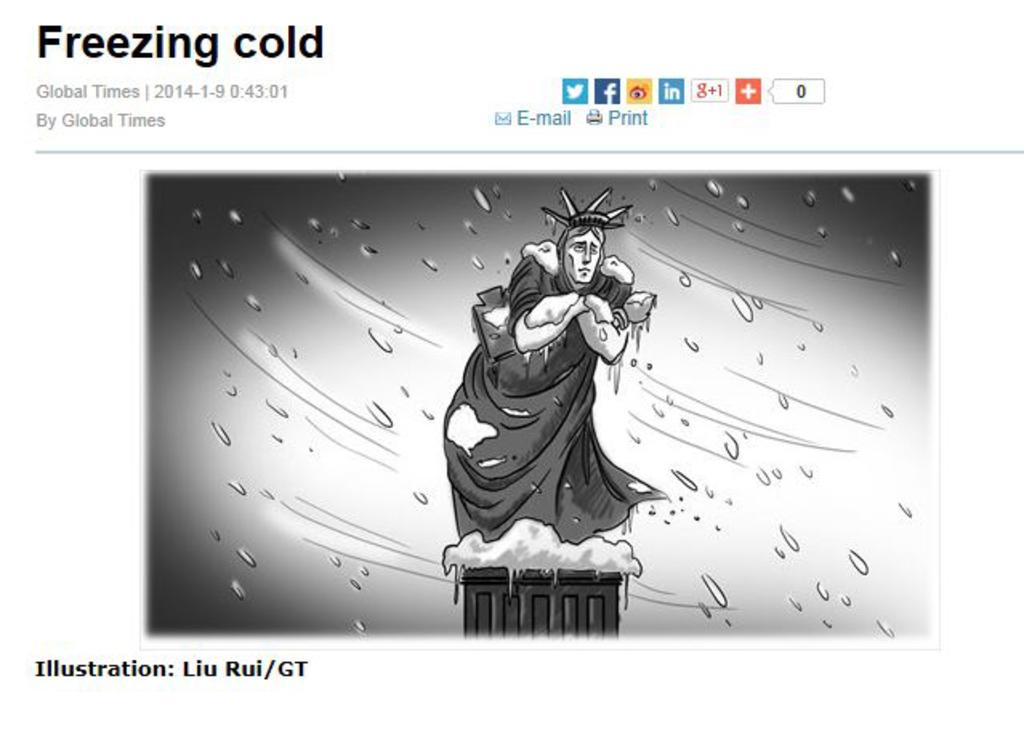What type of image is being described? The image is a poster. What is the main subject of the poster? There is a statue depicted in the poster. Are there any additional elements in the poster? Yes, there are water droplets in the poster. What color is the curtain hanging behind the statue in the poster? There is no curtain present in the poster; it only features a statue and water droplets. 